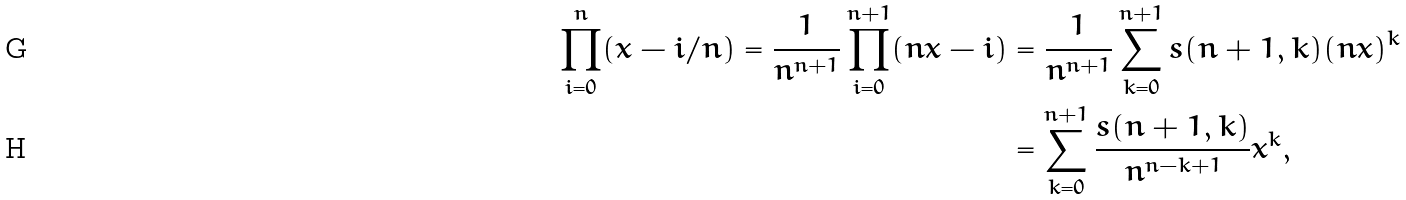<formula> <loc_0><loc_0><loc_500><loc_500>\prod _ { i = 0 } ^ { n } ( x - i / n ) = \frac { 1 } { n ^ { n + 1 } } \prod _ { i = 0 } ^ { n + 1 } ( n x - i ) & = \frac { 1 } { n ^ { n + 1 } } \sum _ { k = 0 } ^ { n + 1 } s ( n + 1 , k ) ( n x ) ^ { k } \\ & = \sum _ { k = 0 } ^ { n + 1 } \frac { s ( n + 1 , k ) } { n ^ { n - k + 1 } } x ^ { k } ,</formula> 